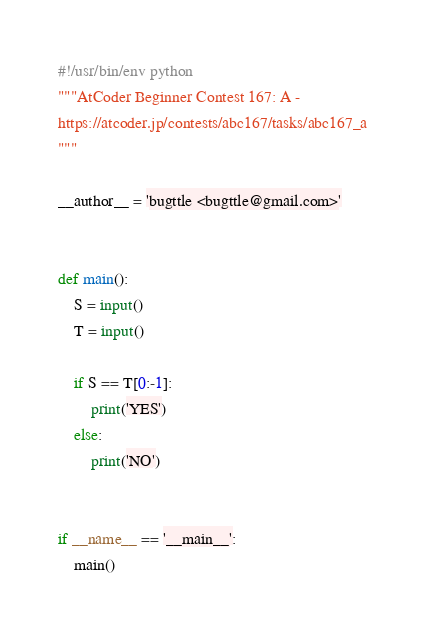<code> <loc_0><loc_0><loc_500><loc_500><_Python_>#!/usr/bin/env python
"""AtCoder Beginner Contest 167: A - 
https://atcoder.jp/contests/abc167/tasks/abc167_a
"""

__author__ = 'bugttle <bugttle@gmail.com>'


def main():
    S = input()
    T = input()

    if S == T[0:-1]:
        print('YES')
    else:
        print('NO')


if __name__ == '__main__':
    main()
</code> 